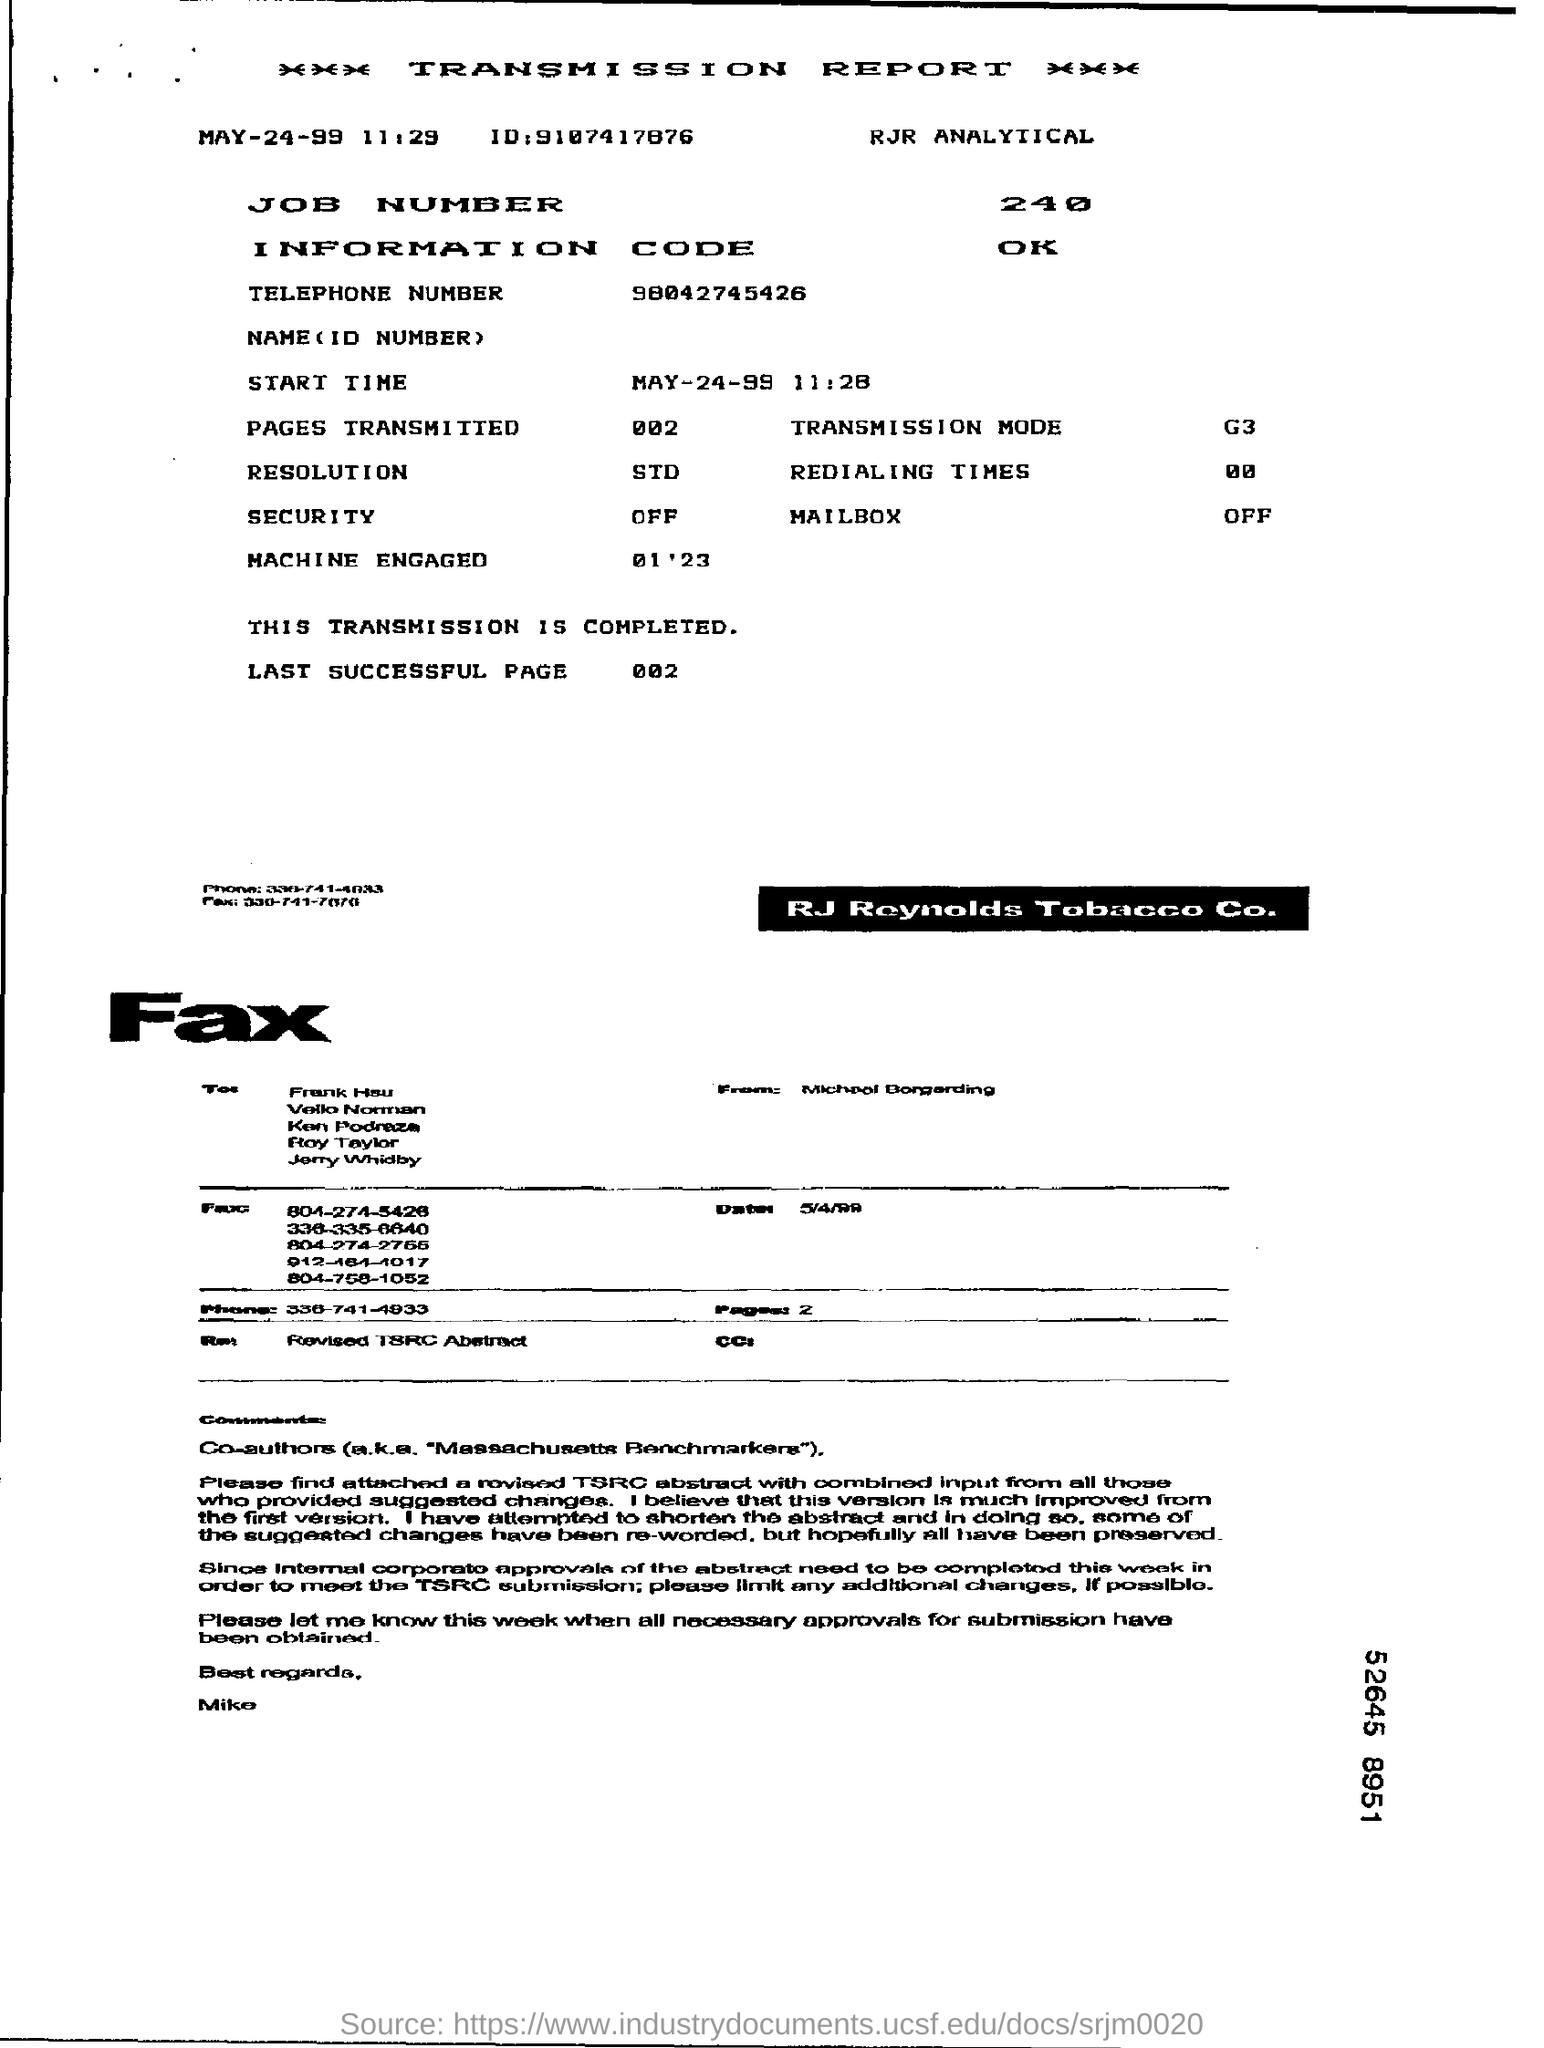What is the heading of the document?
Ensure brevity in your answer.  TRANSMISSION REPORT. What is the date mentioned at the top?
Provide a succinct answer. MAY-24-99. 